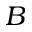Convert formula to latex. <formula><loc_0><loc_0><loc_500><loc_500>B</formula> 